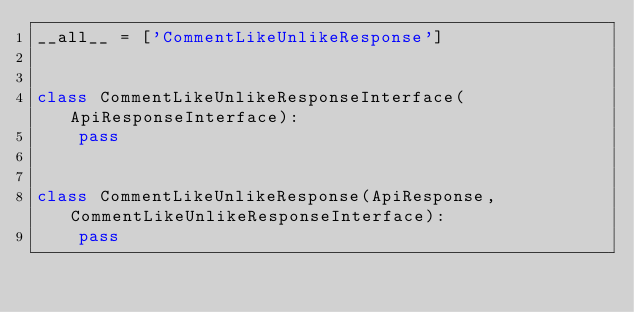Convert code to text. <code><loc_0><loc_0><loc_500><loc_500><_Python_>__all__ = ['CommentLikeUnlikeResponse']


class CommentLikeUnlikeResponseInterface(ApiResponseInterface):
    pass


class CommentLikeUnlikeResponse(ApiResponse, CommentLikeUnlikeResponseInterface):
    pass
</code> 